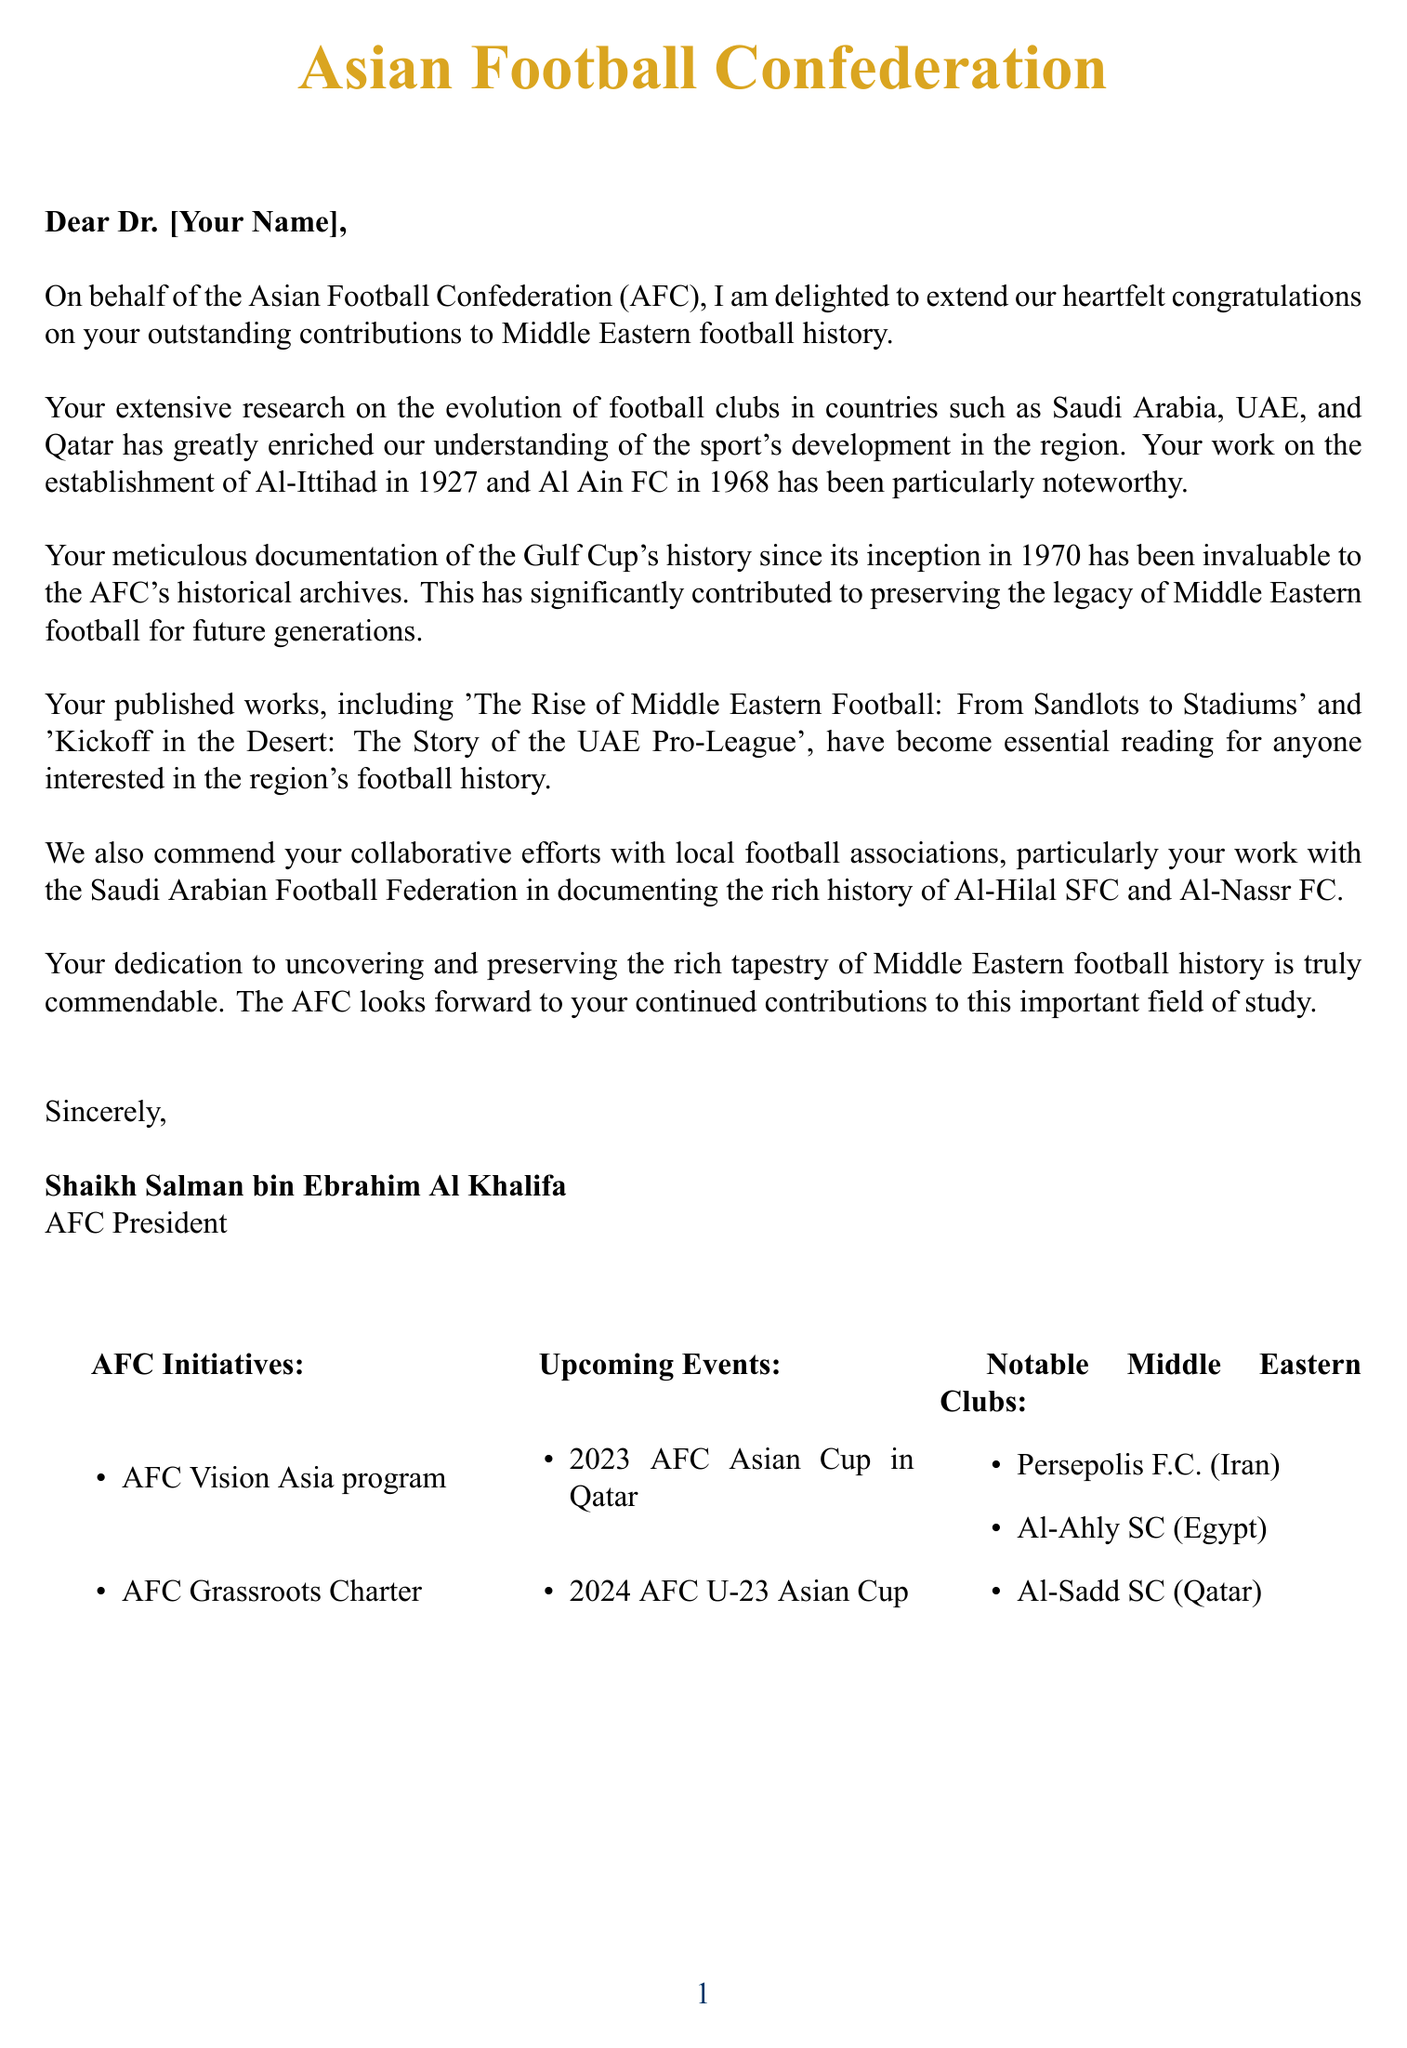What is the title of the letter? The title of the letter is indicated by the organization's name at the beginning, which is the Asian Football Confederation.
Answer: Asian Football Confederation Who sent the letter? The letter is signed by the person who is responsible for sending it, which is identified in the signature section.
Answer: Shaikh Salman bin Ebrahim Al Khalifa What year was the Gulf Cup established? The letter states that the Gulf Cup has been documented since its inception, which was in 1970.
Answer: 1970 Which football club was established in 1927? The letter specifically mentions one football club that was established in 1927, noted for its significance in Middle Eastern football history.
Answer: Al-Ittihad What is the focus of the published work mentioned in the letter? The letter references published works that contribute to the understanding of Middle Eastern football history, providing insights into various aspects.
Answer: History What was the role of the recipient with local football associations? The letter highlights the collaboration of the recipient with local associations in documenting football history, particularly noted for specific clubs.
Answer: Collaborative efforts What are the AFC initiatives mentioned in the letter? The letter lists specific programs that the AFC is promoting, which are initiatives aimed at developing football in the region.
Answer: AFC Vision Asia program, AFC Grassroots Charter What is one of the upcoming events mentioned in the letter? The letter includes a mention of significant upcoming football events organized by the AFC and highlights their importance for the region.
Answer: 2023 AFC Asian Cup in Qatar Which two clubs are specifically mentioned in relation to the Saudi Arabian Football Federation? The letter acknowledges the recipient's efforts in documenting the history of well-known football clubs that are significant in Saudi Arabian football.
Answer: Al-Hilal SFC and Al-Nassr FC 